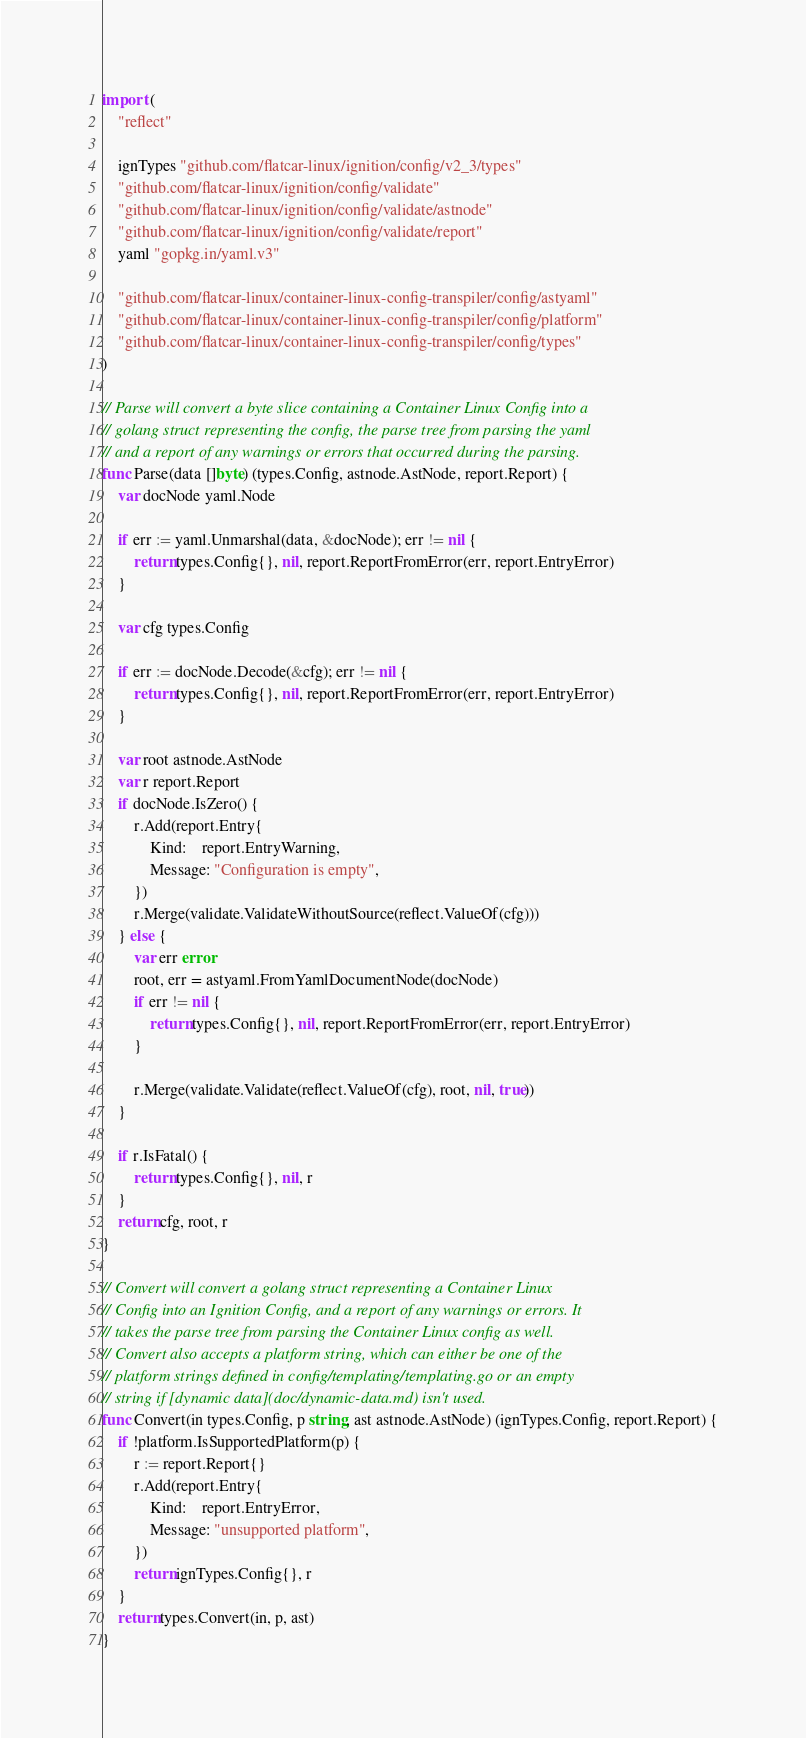<code> <loc_0><loc_0><loc_500><loc_500><_Go_>
import (
	"reflect"

	ignTypes "github.com/flatcar-linux/ignition/config/v2_3/types"
	"github.com/flatcar-linux/ignition/config/validate"
	"github.com/flatcar-linux/ignition/config/validate/astnode"
	"github.com/flatcar-linux/ignition/config/validate/report"
	yaml "gopkg.in/yaml.v3"

	"github.com/flatcar-linux/container-linux-config-transpiler/config/astyaml"
	"github.com/flatcar-linux/container-linux-config-transpiler/config/platform"
	"github.com/flatcar-linux/container-linux-config-transpiler/config/types"
)

// Parse will convert a byte slice containing a Container Linux Config into a
// golang struct representing the config, the parse tree from parsing the yaml
// and a report of any warnings or errors that occurred during the parsing.
func Parse(data []byte) (types.Config, astnode.AstNode, report.Report) {
	var docNode yaml.Node

	if err := yaml.Unmarshal(data, &docNode); err != nil {
		return types.Config{}, nil, report.ReportFromError(err, report.EntryError)
	}

	var cfg types.Config

	if err := docNode.Decode(&cfg); err != nil {
		return types.Config{}, nil, report.ReportFromError(err, report.EntryError)
	}

	var root astnode.AstNode
	var r report.Report
	if docNode.IsZero() {
		r.Add(report.Entry{
			Kind:    report.EntryWarning,
			Message: "Configuration is empty",
		})
		r.Merge(validate.ValidateWithoutSource(reflect.ValueOf(cfg)))
	} else {
		var err error
		root, err = astyaml.FromYamlDocumentNode(docNode)
		if err != nil {
			return types.Config{}, nil, report.ReportFromError(err, report.EntryError)
		}

		r.Merge(validate.Validate(reflect.ValueOf(cfg), root, nil, true))
	}

	if r.IsFatal() {
		return types.Config{}, nil, r
	}
	return cfg, root, r
}

// Convert will convert a golang struct representing a Container Linux
// Config into an Ignition Config, and a report of any warnings or errors. It
// takes the parse tree from parsing the Container Linux config as well.
// Convert also accepts a platform string, which can either be one of the
// platform strings defined in config/templating/templating.go or an empty
// string if [dynamic data](doc/dynamic-data.md) isn't used.
func Convert(in types.Config, p string, ast astnode.AstNode) (ignTypes.Config, report.Report) {
	if !platform.IsSupportedPlatform(p) {
		r := report.Report{}
		r.Add(report.Entry{
			Kind:    report.EntryError,
			Message: "unsupported platform",
		})
		return ignTypes.Config{}, r
	}
	return types.Convert(in, p, ast)
}
</code> 